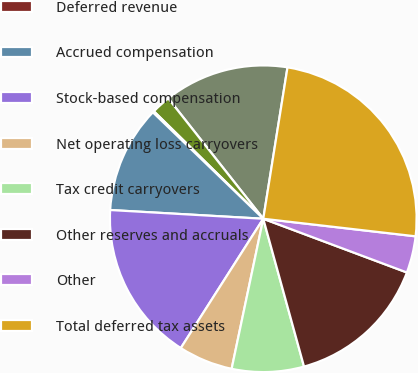Convert chart. <chart><loc_0><loc_0><loc_500><loc_500><pie_chart><fcel>Inventory valuation and<fcel>Distributor related accruals<fcel>Deferred revenue<fcel>Accrued compensation<fcel>Stock-based compensation<fcel>Net operating loss carryovers<fcel>Tax credit carryovers<fcel>Other reserves and accruals<fcel>Other<fcel>Total deferred tax assets<nl><fcel>13.16%<fcel>2.01%<fcel>0.15%<fcel>11.3%<fcel>16.87%<fcel>5.73%<fcel>7.59%<fcel>15.02%<fcel>3.87%<fcel>24.3%<nl></chart> 